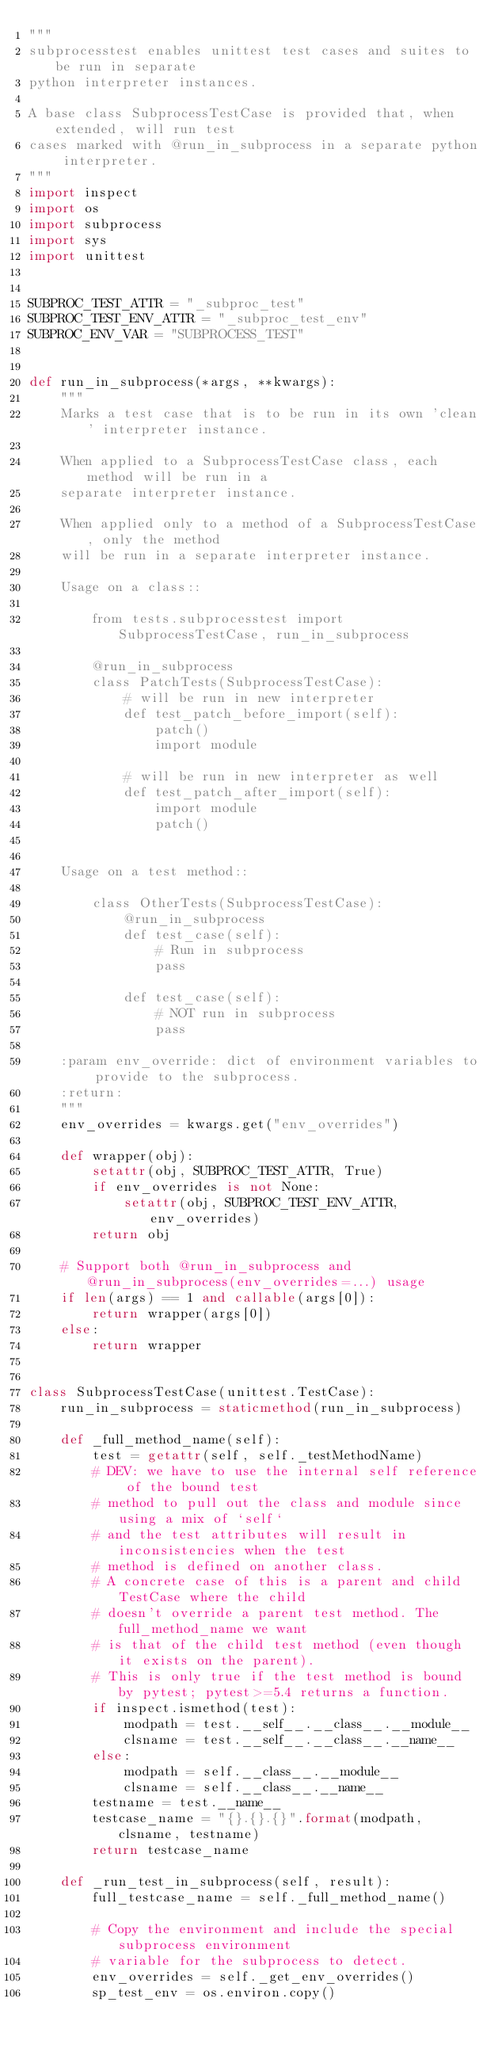<code> <loc_0><loc_0><loc_500><loc_500><_Python_>"""
subprocesstest enables unittest test cases and suites to be run in separate
python interpreter instances.

A base class SubprocessTestCase is provided that, when extended, will run test
cases marked with @run_in_subprocess in a separate python interpreter.
"""
import inspect
import os
import subprocess
import sys
import unittest


SUBPROC_TEST_ATTR = "_subproc_test"
SUBPROC_TEST_ENV_ATTR = "_subproc_test_env"
SUBPROC_ENV_VAR = "SUBPROCESS_TEST"


def run_in_subprocess(*args, **kwargs):
    """
    Marks a test case that is to be run in its own 'clean' interpreter instance.

    When applied to a SubprocessTestCase class, each method will be run in a
    separate interpreter instance.

    When applied only to a method of a SubprocessTestCase, only the method
    will be run in a separate interpreter instance.

    Usage on a class::

        from tests.subprocesstest import SubprocessTestCase, run_in_subprocess

        @run_in_subprocess
        class PatchTests(SubprocessTestCase):
            # will be run in new interpreter
            def test_patch_before_import(self):
                patch()
                import module

            # will be run in new interpreter as well
            def test_patch_after_import(self):
                import module
                patch()


    Usage on a test method::

        class OtherTests(SubprocessTestCase):
            @run_in_subprocess
            def test_case(self):
                # Run in subprocess
                pass

            def test_case(self):
                # NOT run in subprocess
                pass

    :param env_override: dict of environment variables to provide to the subprocess.
    :return:
    """
    env_overrides = kwargs.get("env_overrides")

    def wrapper(obj):
        setattr(obj, SUBPROC_TEST_ATTR, True)
        if env_overrides is not None:
            setattr(obj, SUBPROC_TEST_ENV_ATTR, env_overrides)
        return obj

    # Support both @run_in_subprocess and @run_in_subprocess(env_overrides=...) usage
    if len(args) == 1 and callable(args[0]):
        return wrapper(args[0])
    else:
        return wrapper


class SubprocessTestCase(unittest.TestCase):
    run_in_subprocess = staticmethod(run_in_subprocess)

    def _full_method_name(self):
        test = getattr(self, self._testMethodName)
        # DEV: we have to use the internal self reference of the bound test
        # method to pull out the class and module since using a mix of `self`
        # and the test attributes will result in inconsistencies when the test
        # method is defined on another class.
        # A concrete case of this is a parent and child TestCase where the child
        # doesn't override a parent test method. The full_method_name we want
        # is that of the child test method (even though it exists on the parent).
        # This is only true if the test method is bound by pytest; pytest>=5.4 returns a function.
        if inspect.ismethod(test):
            modpath = test.__self__.__class__.__module__
            clsname = test.__self__.__class__.__name__
        else:
            modpath = self.__class__.__module__
            clsname = self.__class__.__name__
        testname = test.__name__
        testcase_name = "{}.{}.{}".format(modpath, clsname, testname)
        return testcase_name

    def _run_test_in_subprocess(self, result):
        full_testcase_name = self._full_method_name()

        # Copy the environment and include the special subprocess environment
        # variable for the subprocess to detect.
        env_overrides = self._get_env_overrides()
        sp_test_env = os.environ.copy()</code> 